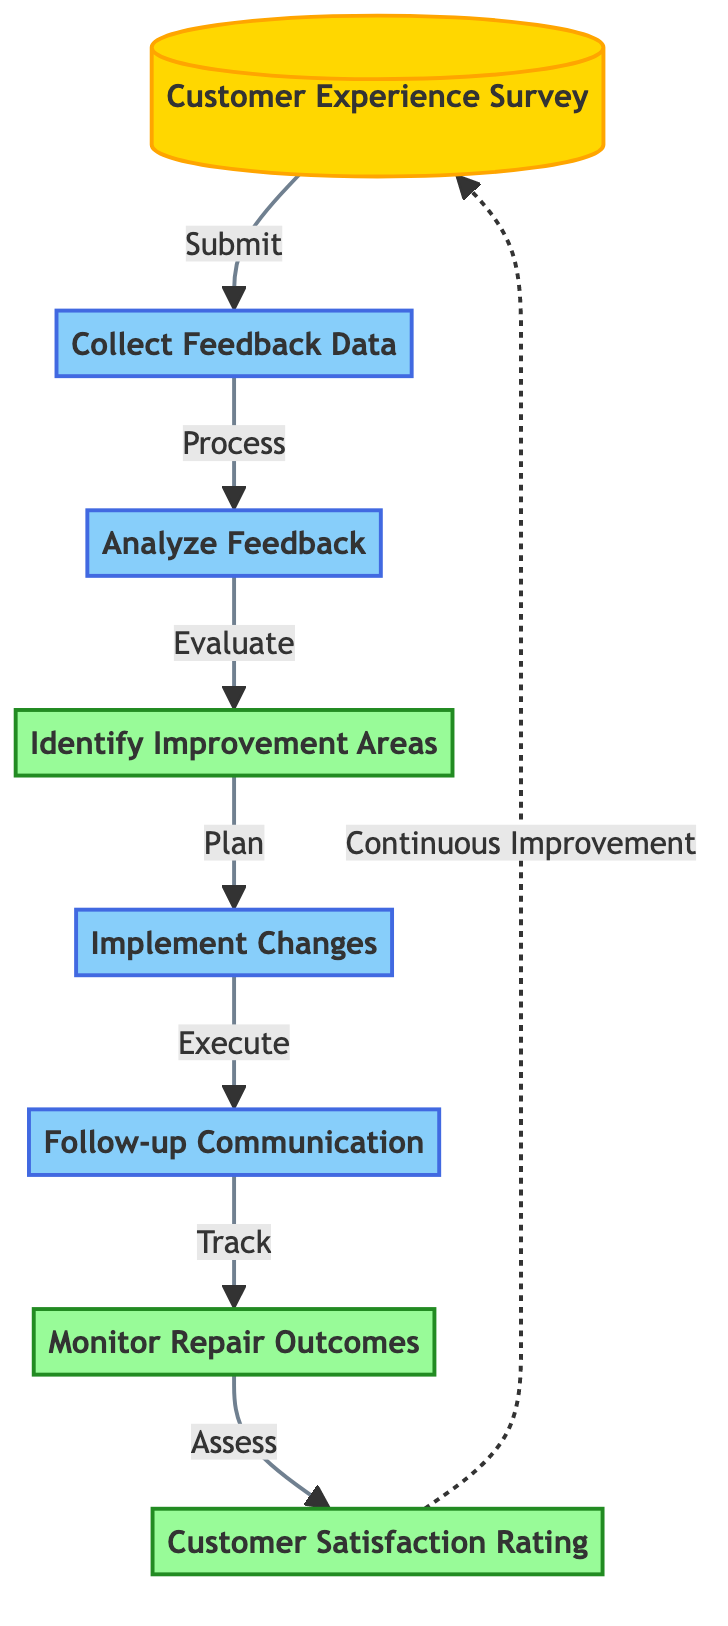What is the first step in the customer feedback loop? The first step in the customer feedback loop is represented by the node labeled "Customer Experience Survey," indicating that customer input is collected initially.
Answer: Customer Experience Survey How many process nodes are included in the flow chart? The flow chart includes four process nodes: "Collect Feedback Data," "Analyze Feedback," "Implement Changes," and "Follow-up Communication." Counting these, we find there are four process nodes.
Answer: 4 What follows after "Analyze Feedback"? After "Analyze Feedback," the next step in the flow chart is "Identify Improvement Areas," which indicates the flow of the process from analyzing the feedback to identifying where improvements can be made.
Answer: Identify Improvement Areas Which output node is connected to the "Follow-up Communication" process? The output node connected to "Follow-up Communication" is "Monitor Repair Outcomes," as it is the next step after the follow-up communication, indicating that the results of repairs are then monitored.
Answer: Monitor Repair Outcomes What type of feedback loop is indicated at the end of the flow chart? The end of the flow chart indicates a "Continuous Improvement" feedback loop leading back to "Customer Experience Survey," suggesting that customer feedback is an ongoing process for effective improvement.
Answer: Continuous Improvement What does the "Customer Satisfaction Rating" output signify in the process? The "Customer Satisfaction Rating" output signifies the measure of success of the entire feedback loop, reflecting how well the improvements and repairs have met customer expectations.
Answer: Customer Satisfaction Rating 